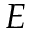<formula> <loc_0><loc_0><loc_500><loc_500>E</formula> 